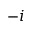Convert formula to latex. <formula><loc_0><loc_0><loc_500><loc_500>- i</formula> 